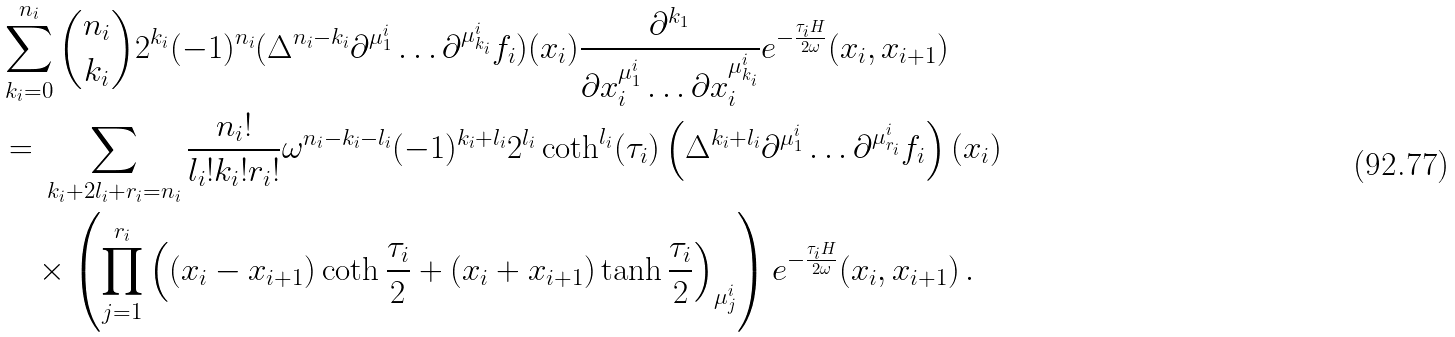Convert formula to latex. <formula><loc_0><loc_0><loc_500><loc_500>& \sum _ { k _ { i } = 0 } ^ { n _ { i } } \binom { n _ { i } } { k _ { i } } 2 ^ { k _ { i } } ( - 1 ) ^ { n _ { i } } ( \Delta ^ { n _ { i } - k _ { i } } \partial ^ { \mu ^ { i } _ { 1 } } \dots \partial ^ { \mu ^ { i } _ { k _ { i } } } f _ { i } ) ( x _ { i } ) \frac { \partial ^ { k _ { 1 } } } { \partial x _ { i } ^ { \mu _ { 1 } ^ { i } } \dots \partial x _ { i } ^ { \mu ^ { i } _ { k _ { i } } } } e ^ { - \frac { \tau _ { i } H } { 2 \omega } } ( x _ { i } , x _ { i + 1 } ) \\ & = \, \sum _ { k _ { i } + 2 l _ { i } + r _ { i } = n _ { i } } \frac { n _ { i } ! } { l _ { i } ! k _ { i } ! r _ { i } ! } \omega ^ { n _ { i } - k _ { i } - l _ { i } } ( - 1 ) ^ { k _ { i } + l _ { i } } 2 ^ { l _ { i } } \coth ^ { l _ { i } } ( \tau _ { i } ) \left ( \Delta ^ { k _ { i } + l _ { i } } \partial ^ { \mu ^ { i } _ { 1 } } \dots \partial ^ { \mu ^ { i } _ { r _ { i } } } f _ { i } \right ) ( x _ { i } ) \\ & \quad \times \left ( \prod _ { j = 1 } ^ { r _ { i } } \left ( ( x _ { i } - x _ { i + 1 } ) \coth \frac { \tau _ { i } } { 2 } + ( x _ { i } + x _ { i + 1 } ) \tanh \frac { \tau _ { i } } { 2 } \right ) _ { \mu ^ { i } _ { j } } \right ) e ^ { - \frac { \tau _ { i } H } { 2 \omega } } ( x _ { i } , x _ { i + 1 } ) \, .</formula> 